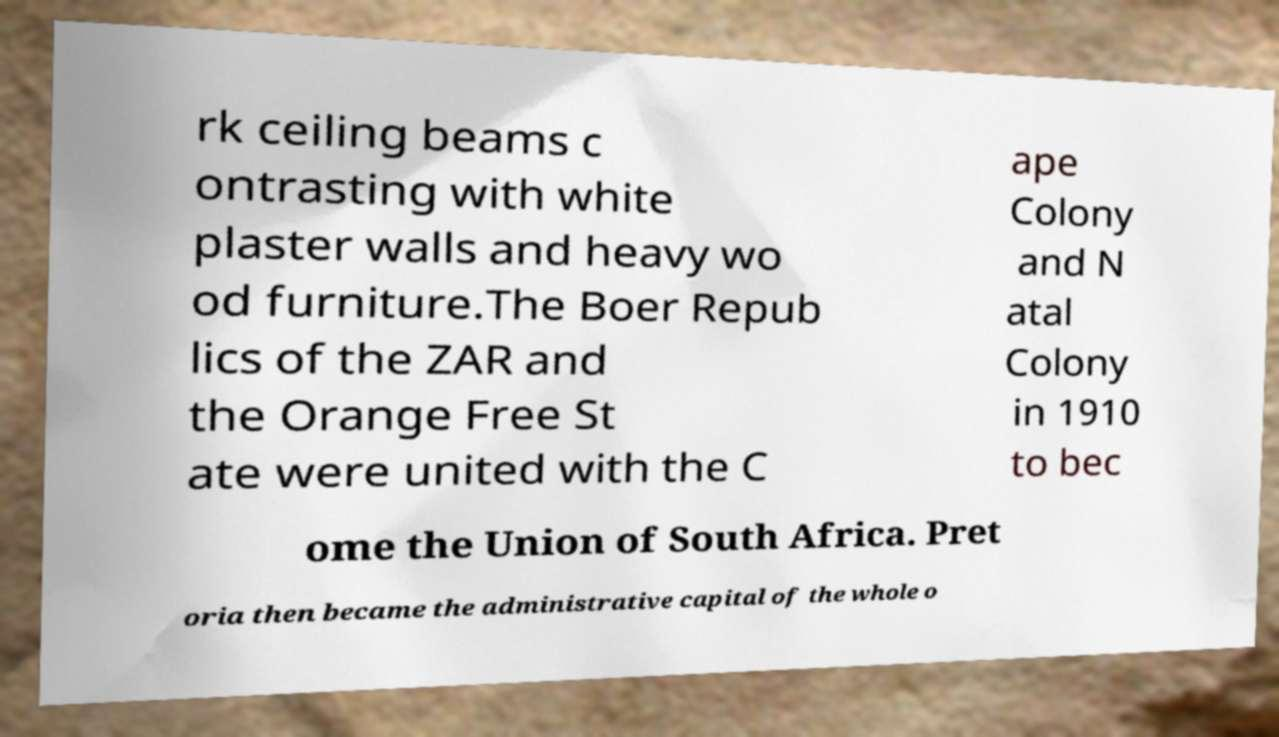Can you read and provide the text displayed in the image?This photo seems to have some interesting text. Can you extract and type it out for me? rk ceiling beams c ontrasting with white plaster walls and heavy wo od furniture.The Boer Repub lics of the ZAR and the Orange Free St ate were united with the C ape Colony and N atal Colony in 1910 to bec ome the Union of South Africa. Pret oria then became the administrative capital of the whole o 